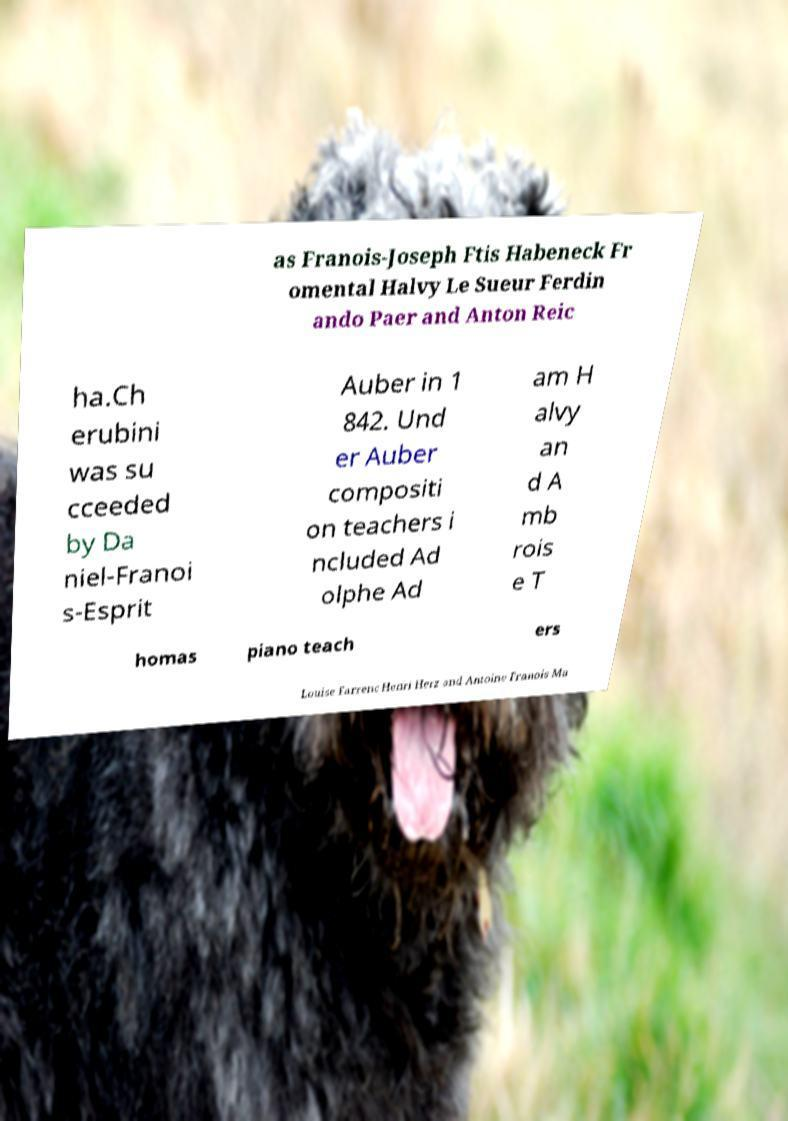For documentation purposes, I need the text within this image transcribed. Could you provide that? as Franois-Joseph Ftis Habeneck Fr omental Halvy Le Sueur Ferdin ando Paer and Anton Reic ha.Ch erubini was su cceeded by Da niel-Franoi s-Esprit Auber in 1 842. Und er Auber compositi on teachers i ncluded Ad olphe Ad am H alvy an d A mb rois e T homas piano teach ers Louise Farrenc Henri Herz and Antoine Franois Ma 